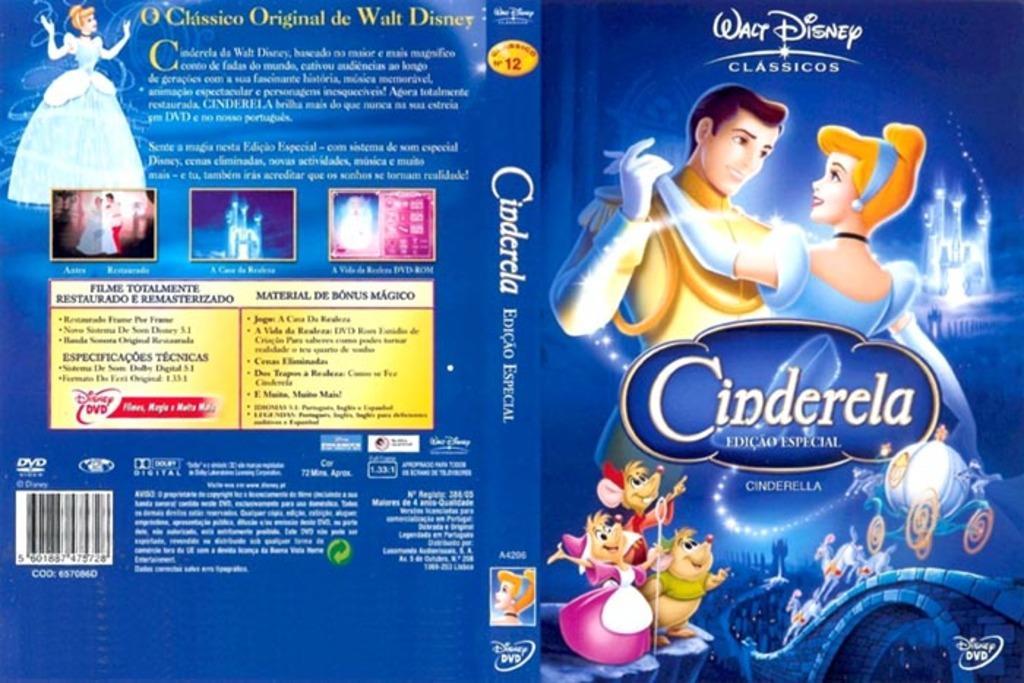In one or two sentences, can you explain what this image depicts? This is a poster. On this poster we can see cartoons. 